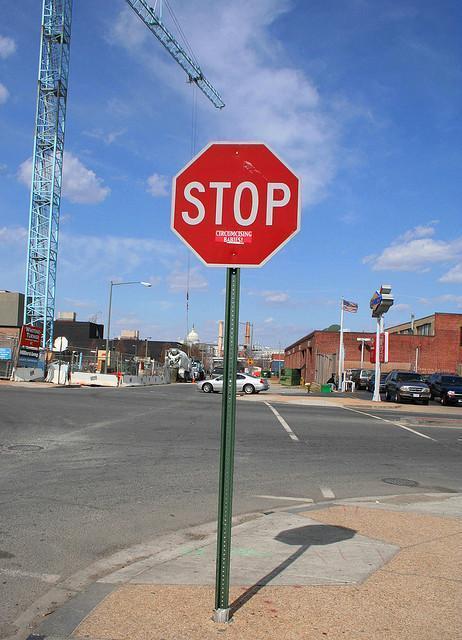How many windows are above the clock face?
Give a very brief answer. 0. 